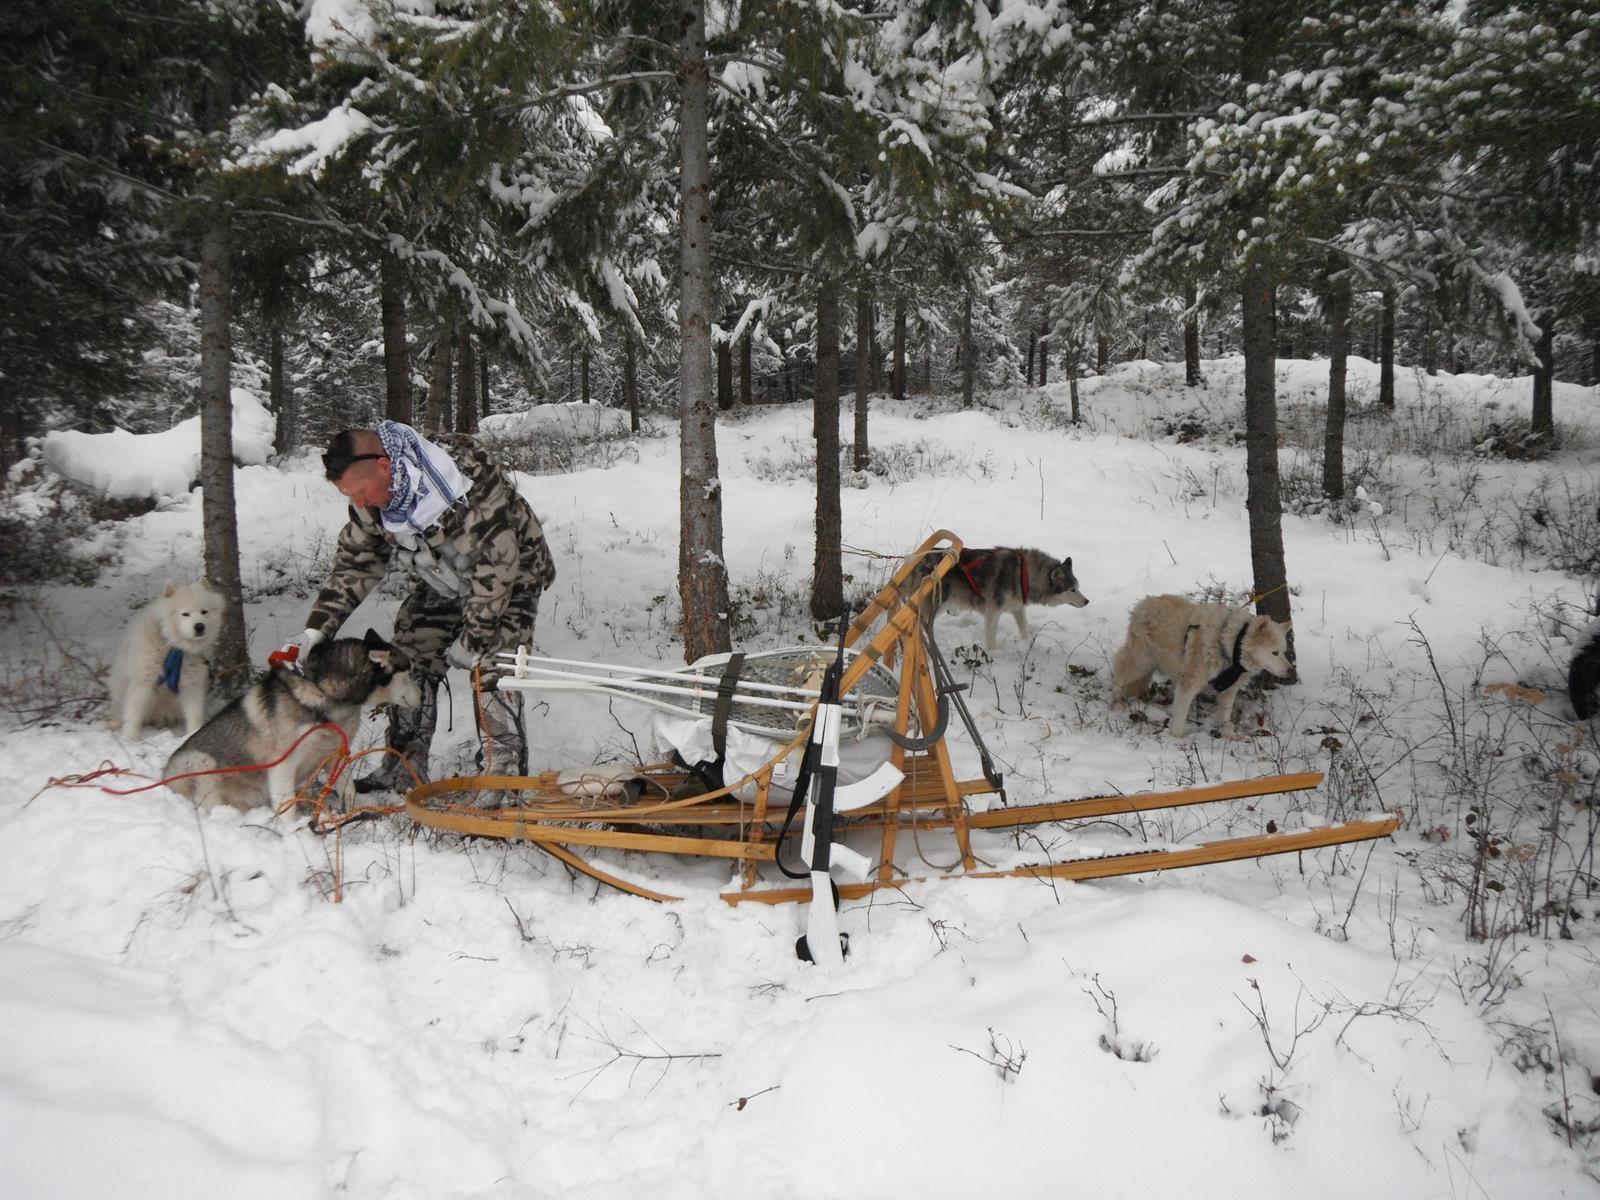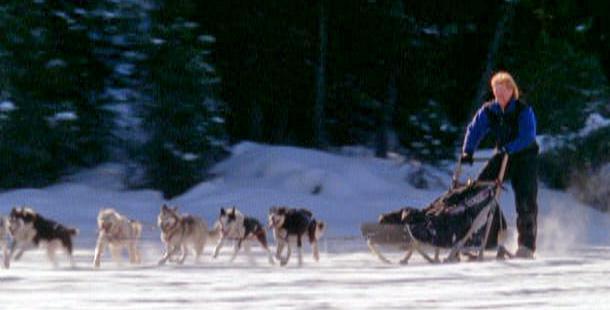The first image is the image on the left, the second image is the image on the right. Evaluate the accuracy of this statement regarding the images: "All the dogs are moving forward.". Is it true? Answer yes or no. No. The first image is the image on the left, the second image is the image on the right. Examine the images to the left and right. Is the description "The dog-pulled sleds in the left and right images move forward over snow at a leftward angle." accurate? Answer yes or no. No. 